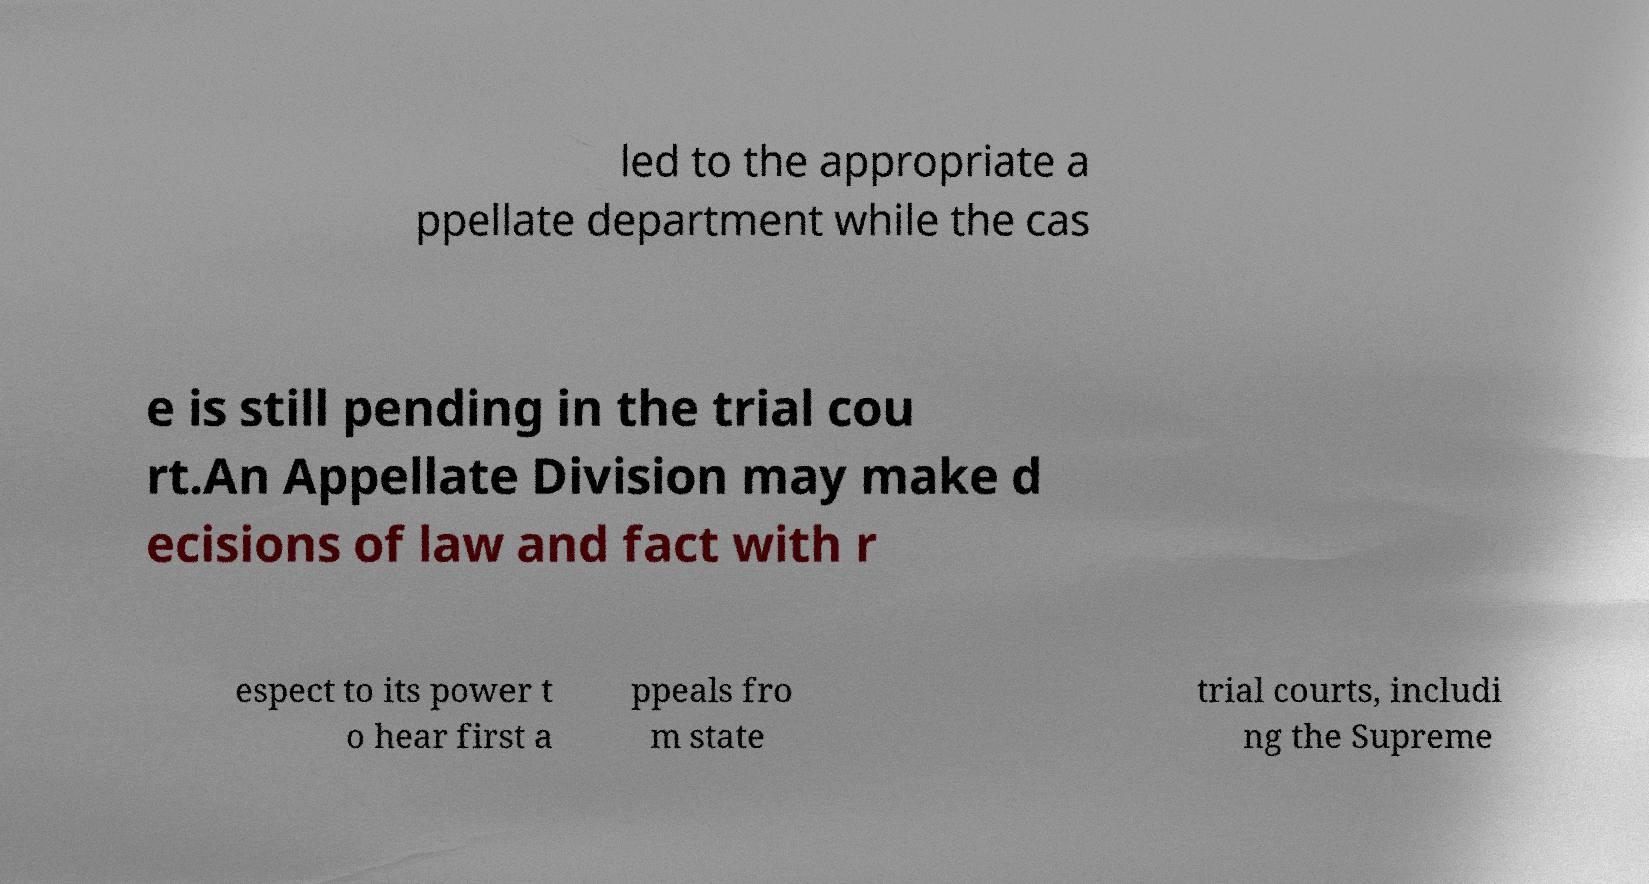Please identify and transcribe the text found in this image. led to the appropriate a ppellate department while the cas e is still pending in the trial cou rt.An Appellate Division may make d ecisions of law and fact with r espect to its power t o hear first a ppeals fro m state trial courts, includi ng the Supreme 